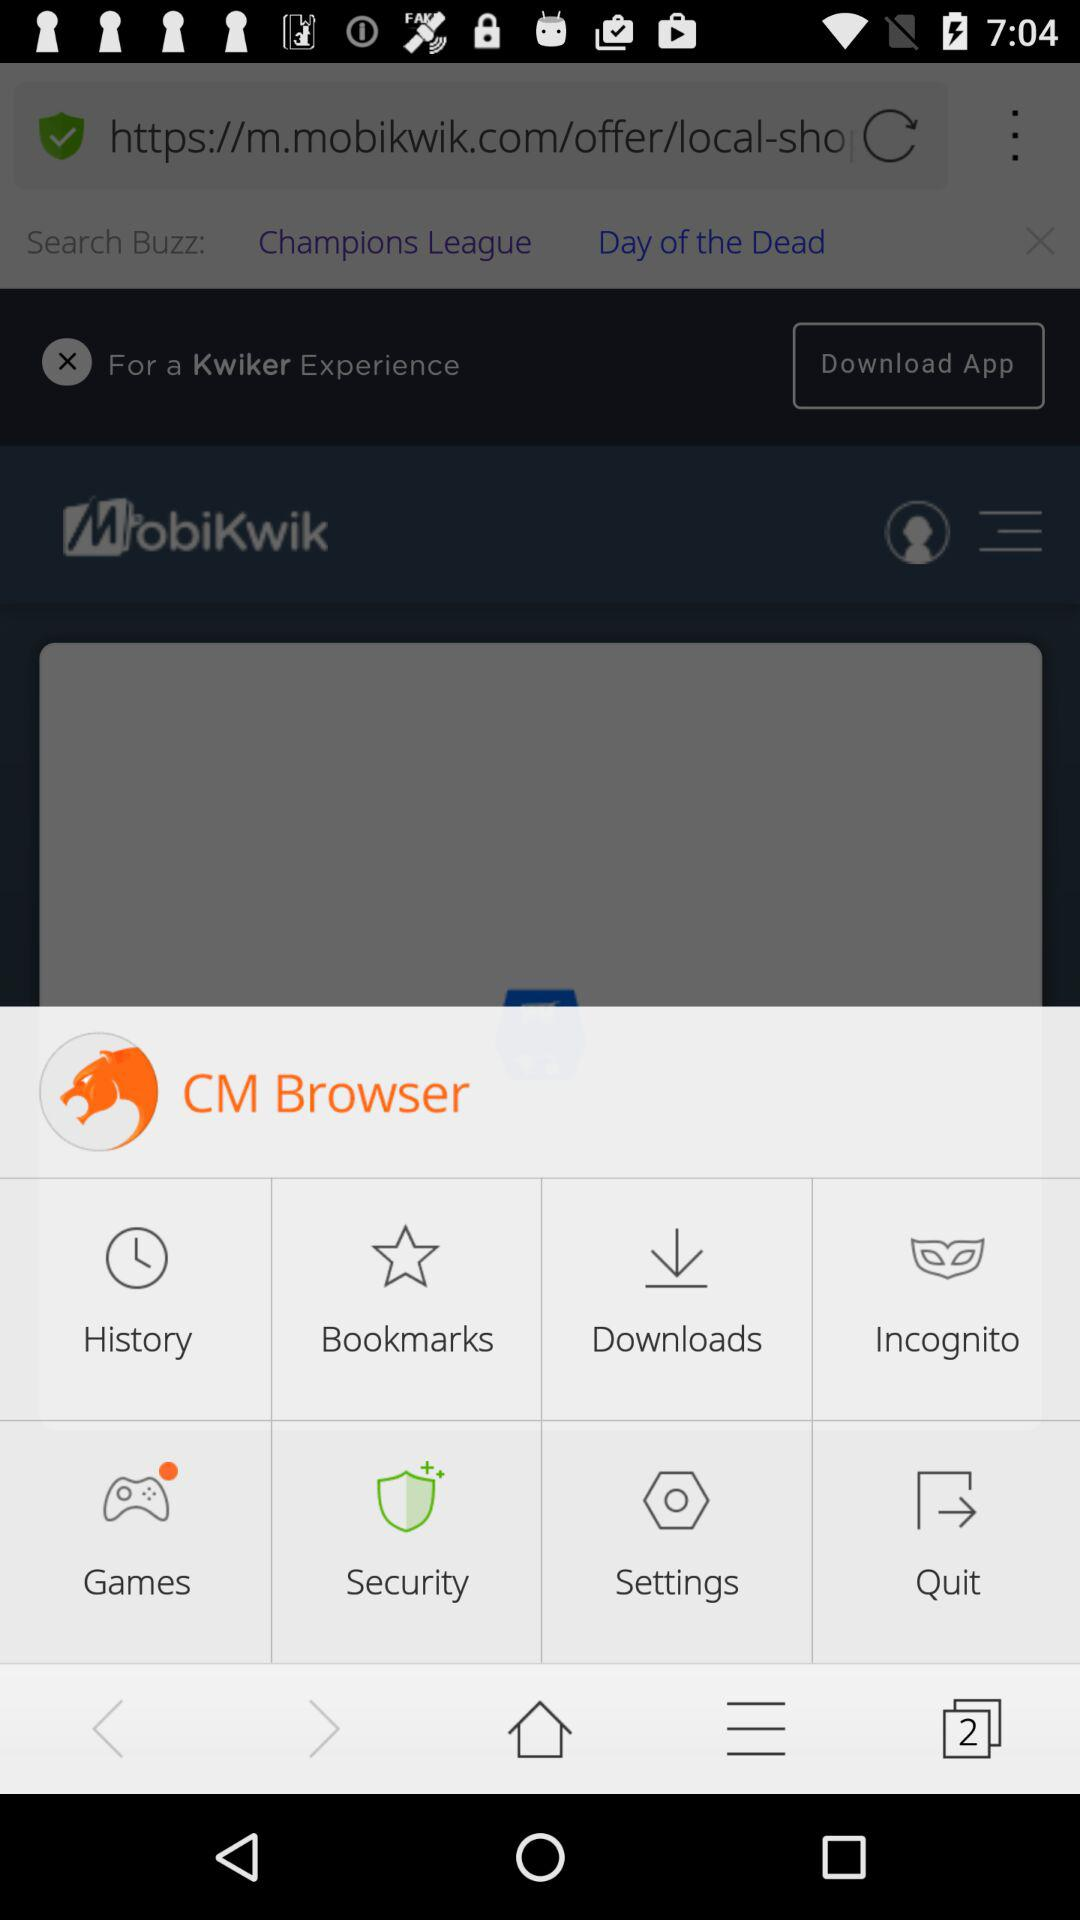How many notifications are in "Games"?
When the provided information is insufficient, respond with <no answer>. <no answer> 